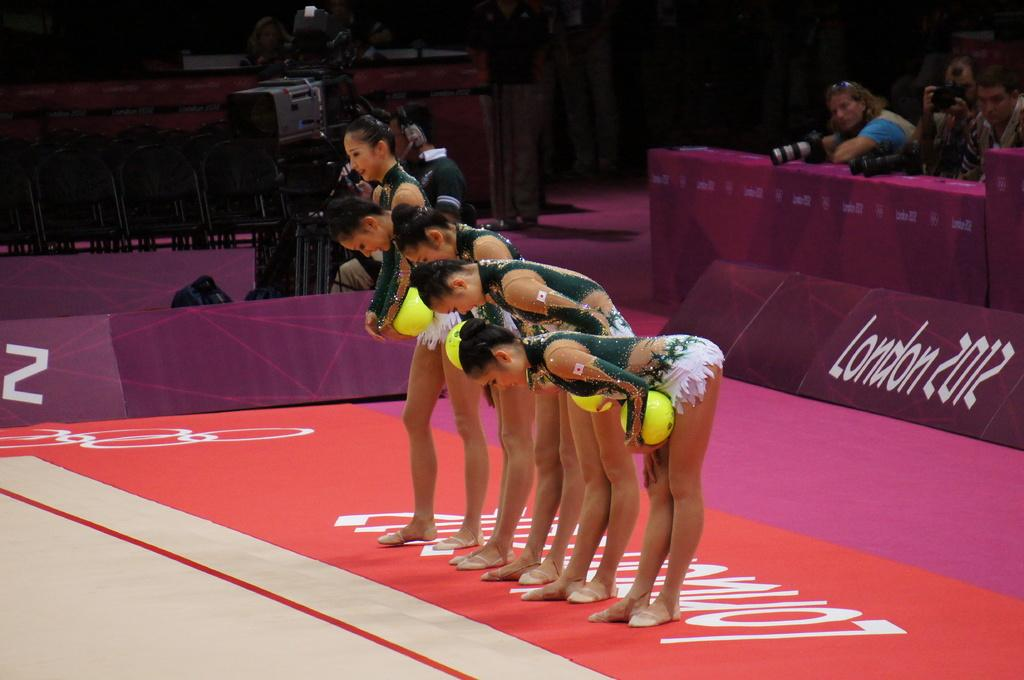<image>
Summarize the visual content of the image. A team of women's gymnasts takes a bow, in front of  a sign saying, "London 2012". 